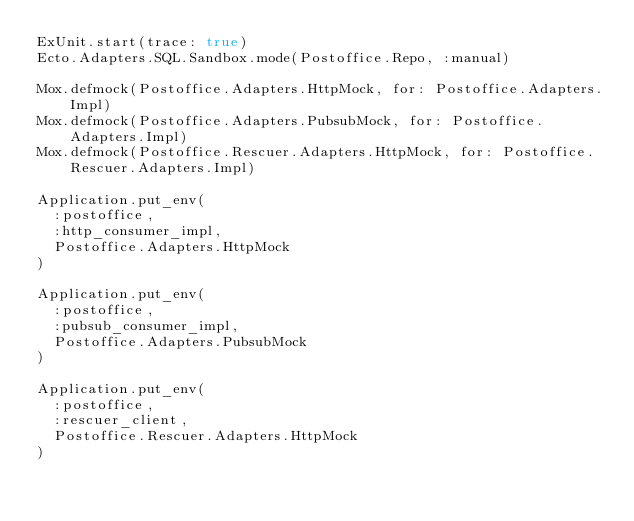Convert code to text. <code><loc_0><loc_0><loc_500><loc_500><_Elixir_>ExUnit.start(trace: true)
Ecto.Adapters.SQL.Sandbox.mode(Postoffice.Repo, :manual)

Mox.defmock(Postoffice.Adapters.HttpMock, for: Postoffice.Adapters.Impl)
Mox.defmock(Postoffice.Adapters.PubsubMock, for: Postoffice.Adapters.Impl)
Mox.defmock(Postoffice.Rescuer.Adapters.HttpMock, for: Postoffice.Rescuer.Adapters.Impl)

Application.put_env(
  :postoffice,
  :http_consumer_impl,
  Postoffice.Adapters.HttpMock
)

Application.put_env(
  :postoffice,
  :pubsub_consumer_impl,
  Postoffice.Adapters.PubsubMock
)

Application.put_env(
  :postoffice,
  :rescuer_client,
  Postoffice.Rescuer.Adapters.HttpMock
)
</code> 